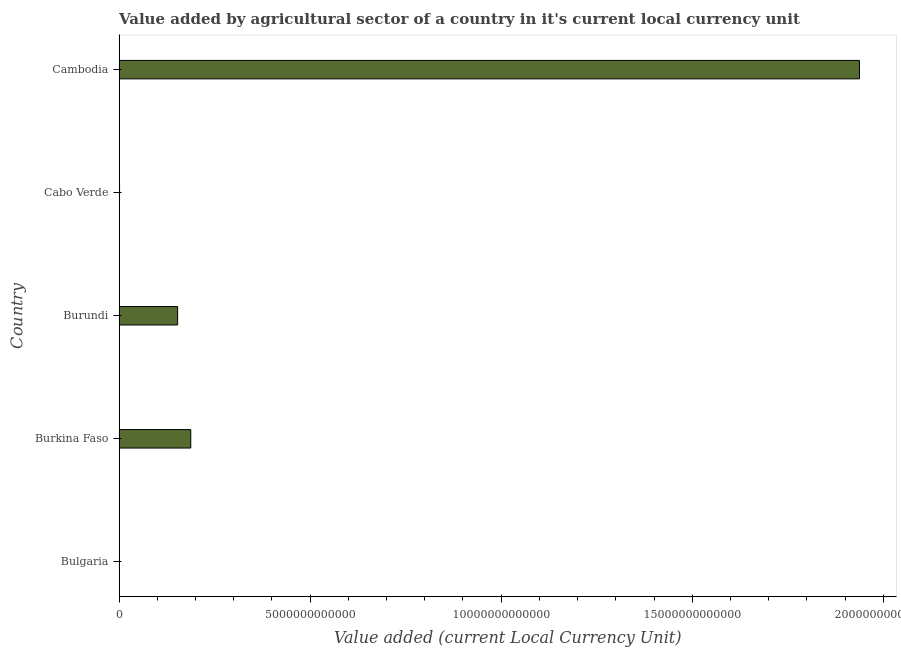Does the graph contain grids?
Provide a short and direct response. No. What is the title of the graph?
Keep it short and to the point. Value added by agricultural sector of a country in it's current local currency unit. What is the label or title of the X-axis?
Provide a short and direct response. Value added (current Local Currency Unit). What is the label or title of the Y-axis?
Provide a succinct answer. Country. What is the value added by agriculture sector in Burkina Faso?
Offer a very short reply. 1.88e+12. Across all countries, what is the maximum value added by agriculture sector?
Give a very brief answer. 1.94e+13. Across all countries, what is the minimum value added by agriculture sector?
Offer a very short reply. 3.77e+09. In which country was the value added by agriculture sector maximum?
Provide a short and direct response. Cambodia. What is the sum of the value added by agriculture sector?
Make the answer very short. 2.28e+13. What is the difference between the value added by agriculture sector in Burkina Faso and Cambodia?
Your answer should be compact. -1.75e+13. What is the average value added by agriculture sector per country?
Give a very brief answer. 4.56e+12. What is the median value added by agriculture sector?
Your answer should be compact. 1.53e+12. What is the ratio of the value added by agriculture sector in Bulgaria to that in Burundi?
Make the answer very short. 0. Is the value added by agriculture sector in Bulgaria less than that in Burundi?
Provide a short and direct response. Yes. Is the difference between the value added by agriculture sector in Burundi and Cambodia greater than the difference between any two countries?
Your answer should be very brief. No. What is the difference between the highest and the second highest value added by agriculture sector?
Your response must be concise. 1.75e+13. What is the difference between the highest and the lowest value added by agriculture sector?
Keep it short and to the point. 1.94e+13. In how many countries, is the value added by agriculture sector greater than the average value added by agriculture sector taken over all countries?
Offer a very short reply. 1. Are all the bars in the graph horizontal?
Provide a succinct answer. Yes. What is the difference between two consecutive major ticks on the X-axis?
Give a very brief answer. 5.00e+12. Are the values on the major ticks of X-axis written in scientific E-notation?
Ensure brevity in your answer.  No. What is the Value added (current Local Currency Unit) of Bulgaria?
Your answer should be compact. 3.77e+09. What is the Value added (current Local Currency Unit) in Burkina Faso?
Provide a succinct answer. 1.88e+12. What is the Value added (current Local Currency Unit) of Burundi?
Offer a very short reply. 1.53e+12. What is the Value added (current Local Currency Unit) of Cabo Verde?
Offer a terse response. 1.29e+1. What is the Value added (current Local Currency Unit) in Cambodia?
Ensure brevity in your answer.  1.94e+13. What is the difference between the Value added (current Local Currency Unit) in Bulgaria and Burkina Faso?
Make the answer very short. -1.87e+12. What is the difference between the Value added (current Local Currency Unit) in Bulgaria and Burundi?
Provide a short and direct response. -1.53e+12. What is the difference between the Value added (current Local Currency Unit) in Bulgaria and Cabo Verde?
Your response must be concise. -9.15e+09. What is the difference between the Value added (current Local Currency Unit) in Bulgaria and Cambodia?
Your answer should be compact. -1.94e+13. What is the difference between the Value added (current Local Currency Unit) in Burkina Faso and Burundi?
Provide a succinct answer. 3.44e+11. What is the difference between the Value added (current Local Currency Unit) in Burkina Faso and Cabo Verde?
Keep it short and to the point. 1.86e+12. What is the difference between the Value added (current Local Currency Unit) in Burkina Faso and Cambodia?
Provide a short and direct response. -1.75e+13. What is the difference between the Value added (current Local Currency Unit) in Burundi and Cabo Verde?
Make the answer very short. 1.52e+12. What is the difference between the Value added (current Local Currency Unit) in Burundi and Cambodia?
Your answer should be very brief. -1.78e+13. What is the difference between the Value added (current Local Currency Unit) in Cabo Verde and Cambodia?
Your response must be concise. -1.94e+13. What is the ratio of the Value added (current Local Currency Unit) in Bulgaria to that in Burkina Faso?
Keep it short and to the point. 0. What is the ratio of the Value added (current Local Currency Unit) in Bulgaria to that in Burundi?
Provide a short and direct response. 0. What is the ratio of the Value added (current Local Currency Unit) in Bulgaria to that in Cabo Verde?
Your response must be concise. 0.29. What is the ratio of the Value added (current Local Currency Unit) in Burkina Faso to that in Burundi?
Provide a short and direct response. 1.22. What is the ratio of the Value added (current Local Currency Unit) in Burkina Faso to that in Cabo Verde?
Ensure brevity in your answer.  145.28. What is the ratio of the Value added (current Local Currency Unit) in Burkina Faso to that in Cambodia?
Give a very brief answer. 0.1. What is the ratio of the Value added (current Local Currency Unit) in Burundi to that in Cabo Verde?
Give a very brief answer. 118.67. What is the ratio of the Value added (current Local Currency Unit) in Burundi to that in Cambodia?
Provide a short and direct response. 0.08. 